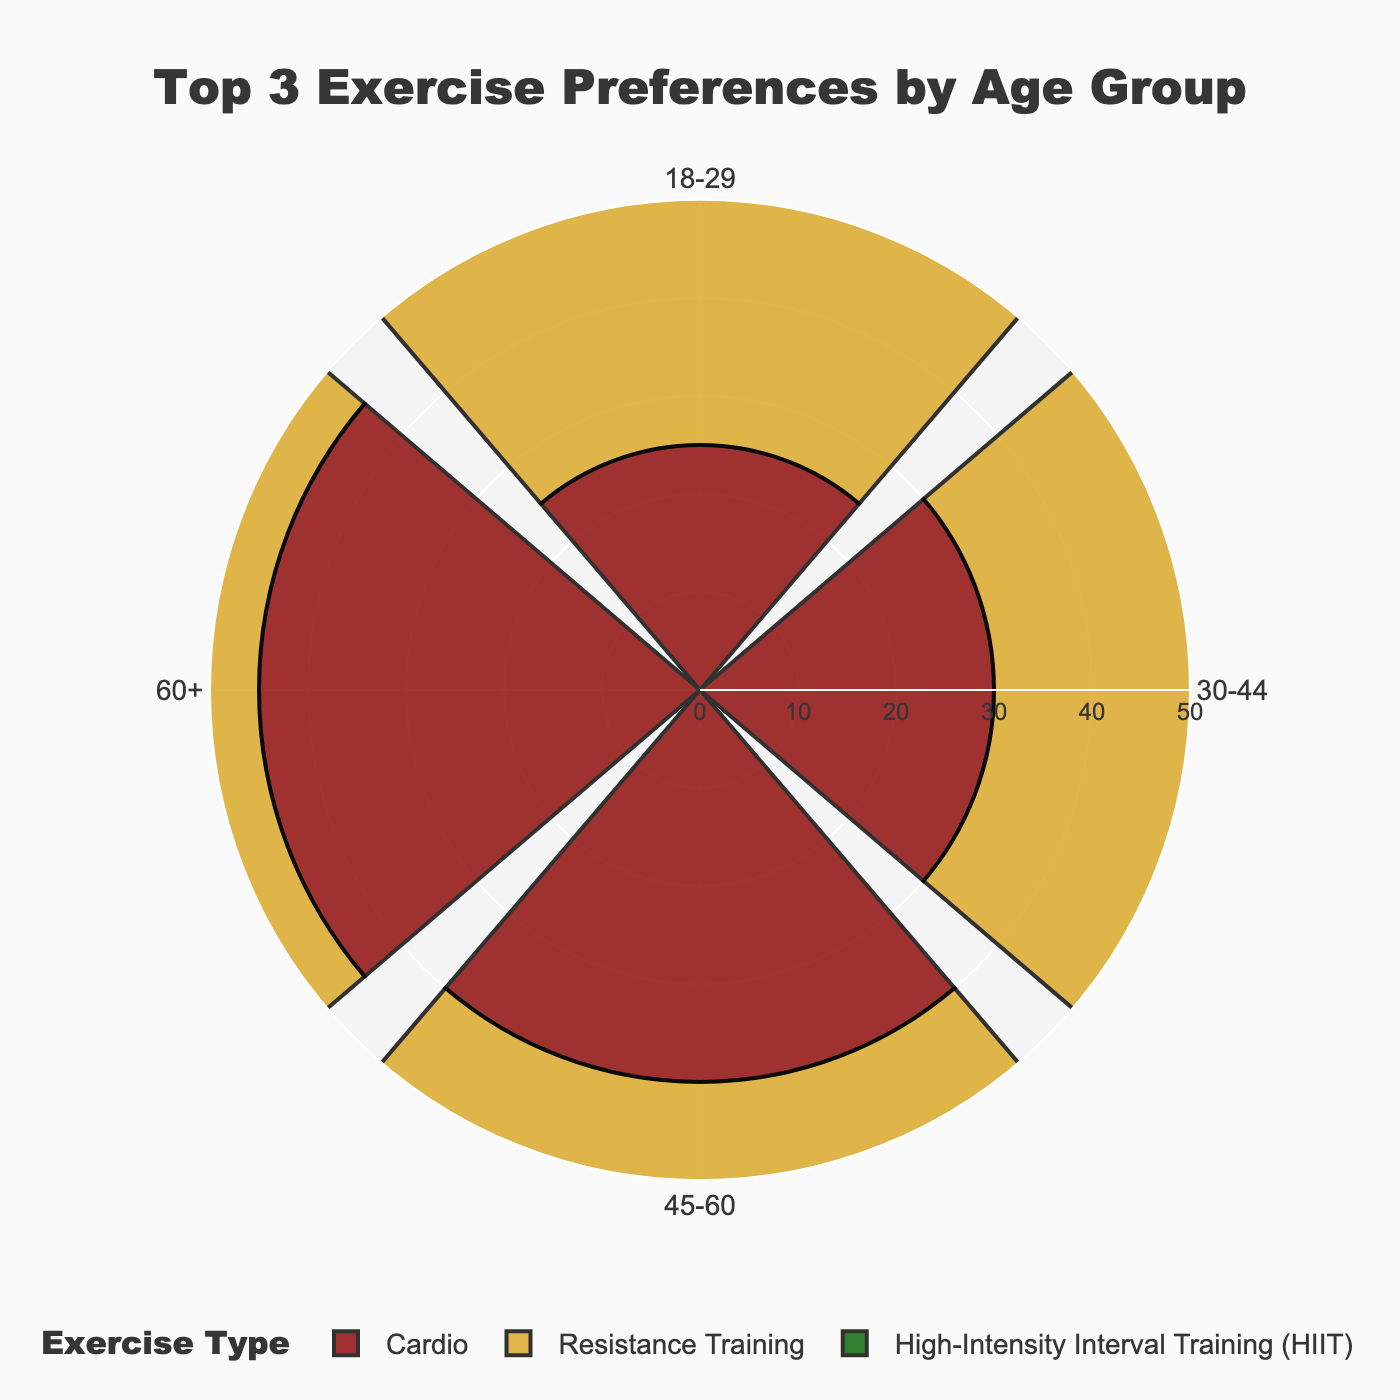What is the title of the figure? The title is displayed prominently at the top of the figure, which helps identify the focus of the visualization.
Answer: Top 3 Exercise Preferences by Age Group Which exercise type does the 18-29 age group prefer the most? By examining the bars extending from the center for the 18-29 group, the longest bar represents the exercise type.
Answer: High-Intensity Interval Training (HIIT) Among the age groups, which group prefers Cardio the most? Look at the height of the bars indicating "Cardio" for all age groups and identify the one with the highest bar.
Answer: 60+ What is the sum of preferred resistance training for age groups 18-29 and 60+? Identify the bars corresponding to "Resistance Training" for the 18-29 and 60+ age groups, then add the two numbers together: 30 (18-29) + 30 (60+).
Answer: 60 How much less popular is Yoga among the 45-60 age group compared to Cardio among the same group? Identify the bar lengths for "Yoga" and "Cardio" in the 45-60 age group, subtract the shorter value (Yoga) from the longer value (Cardio): 40 (Cardio) - 10 (Yoga).
Answer: 30 Which age group has the lowest preference for High-Intensity Interval Training (HIIT)? Compare the bars representing "High-Intensity Interval Training (HIIT)" for all age groups and identify the smallest one.
Answer: 60+ Compare the popularity of Cardio between the age groups 30-44 and 45-60. Which group prefers it more and by how much? Look at the bars representing "Cardio" for both 30-44 and 45-60 age groups. Subtract the smaller value (30-44) from the larger value (45-60): 40 (45-60) - 30 (30-44).
Answer: 45-60 by 10 Which exercise type in the 60+ age group has the second-highest preference? Identify the bars representing different exercise types for the 60+ age group and determine the second-longest bar.
Answer: Yoga How does the preference for Resistance Training change across the age groups? Examine the bars representing "Resistance Training" across all age groups and describe the pattern.
Answer: 30, 40, 35, 30 If you sum up the preferences for High-Intensity Interval Training (HIIT) across all age groups, what is the total? Add the bar lengths for "High-Intensity Interval Training (HIIT)" for each age group: 35 (18-29) + 20 (30-44) + 15 (45-60) + 10 (60+).
Answer: 80 